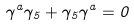<formula> <loc_0><loc_0><loc_500><loc_500>\gamma ^ { a } \gamma _ { 5 } + \gamma _ { 5 } \gamma ^ { a } = 0</formula> 